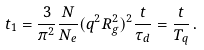Convert formula to latex. <formula><loc_0><loc_0><loc_500><loc_500>t _ { 1 } = \frac { 3 } { \pi ^ { 2 } } \frac { N } { N _ { e } } ( q ^ { 2 } R _ { g } ^ { 2 } ) ^ { 2 } \frac { t } { \tau _ { d } } = \frac { t } { T _ { q } } \, .</formula> 